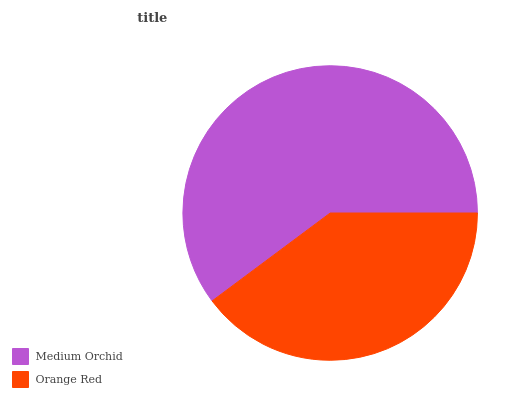Is Orange Red the minimum?
Answer yes or no. Yes. Is Medium Orchid the maximum?
Answer yes or no. Yes. Is Orange Red the maximum?
Answer yes or no. No. Is Medium Orchid greater than Orange Red?
Answer yes or no. Yes. Is Orange Red less than Medium Orchid?
Answer yes or no. Yes. Is Orange Red greater than Medium Orchid?
Answer yes or no. No. Is Medium Orchid less than Orange Red?
Answer yes or no. No. Is Medium Orchid the high median?
Answer yes or no. Yes. Is Orange Red the low median?
Answer yes or no. Yes. Is Orange Red the high median?
Answer yes or no. No. Is Medium Orchid the low median?
Answer yes or no. No. 